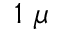<formula> <loc_0><loc_0><loc_500><loc_500>1 \ \mu</formula> 